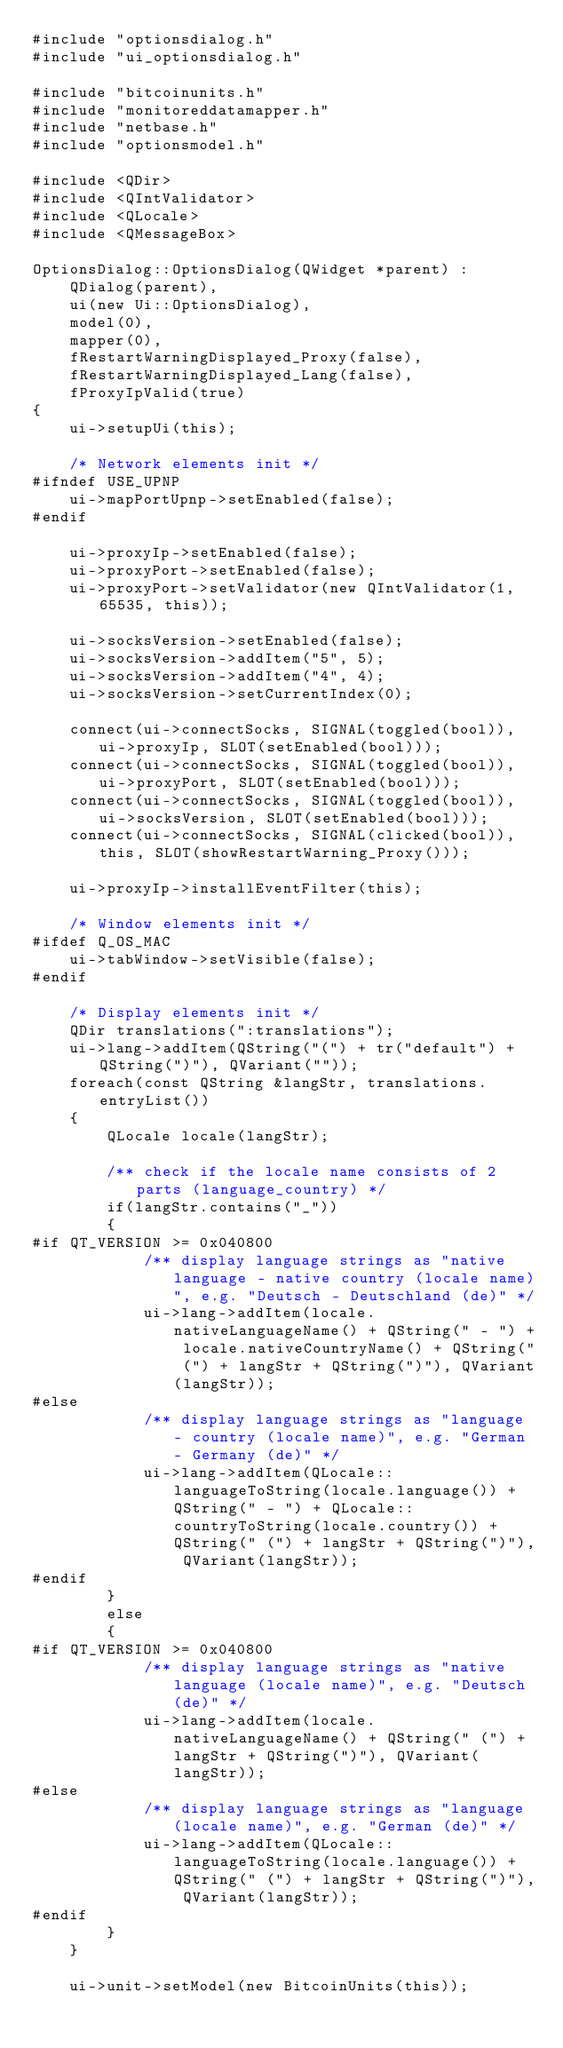Convert code to text. <code><loc_0><loc_0><loc_500><loc_500><_C++_>#include "optionsdialog.h"
#include "ui_optionsdialog.h"

#include "bitcoinunits.h"
#include "monitoreddatamapper.h"
#include "netbase.h"
#include "optionsmodel.h"

#include <QDir>
#include <QIntValidator>
#include <QLocale>
#include <QMessageBox>

OptionsDialog::OptionsDialog(QWidget *parent) :
    QDialog(parent),
    ui(new Ui::OptionsDialog),
    model(0),
    mapper(0),
    fRestartWarningDisplayed_Proxy(false),
    fRestartWarningDisplayed_Lang(false),
    fProxyIpValid(true)
{
    ui->setupUi(this);

    /* Network elements init */
#ifndef USE_UPNP
    ui->mapPortUpnp->setEnabled(false);
#endif

    ui->proxyIp->setEnabled(false);
    ui->proxyPort->setEnabled(false);
    ui->proxyPort->setValidator(new QIntValidator(1, 65535, this));

    ui->socksVersion->setEnabled(false);
    ui->socksVersion->addItem("5", 5);
    ui->socksVersion->addItem("4", 4);
    ui->socksVersion->setCurrentIndex(0);

    connect(ui->connectSocks, SIGNAL(toggled(bool)), ui->proxyIp, SLOT(setEnabled(bool)));
    connect(ui->connectSocks, SIGNAL(toggled(bool)), ui->proxyPort, SLOT(setEnabled(bool)));
    connect(ui->connectSocks, SIGNAL(toggled(bool)), ui->socksVersion, SLOT(setEnabled(bool)));
    connect(ui->connectSocks, SIGNAL(clicked(bool)), this, SLOT(showRestartWarning_Proxy()));

    ui->proxyIp->installEventFilter(this);

    /* Window elements init */
#ifdef Q_OS_MAC
    ui->tabWindow->setVisible(false);
#endif

    /* Display elements init */
    QDir translations(":translations");
    ui->lang->addItem(QString("(") + tr("default") + QString(")"), QVariant(""));
    foreach(const QString &langStr, translations.entryList())
    {
        QLocale locale(langStr);

        /** check if the locale name consists of 2 parts (language_country) */
        if(langStr.contains("_"))
        {
#if QT_VERSION >= 0x040800
            /** display language strings as "native language - native country (locale name)", e.g. "Deutsch - Deutschland (de)" */
            ui->lang->addItem(locale.nativeLanguageName() + QString(" - ") + locale.nativeCountryName() + QString(" (") + langStr + QString(")"), QVariant(langStr));
#else
            /** display language strings as "language - country (locale name)", e.g. "German - Germany (de)" */
            ui->lang->addItem(QLocale::languageToString(locale.language()) + QString(" - ") + QLocale::countryToString(locale.country()) + QString(" (") + langStr + QString(")"), QVariant(langStr));
#endif
        }
        else
        {
#if QT_VERSION >= 0x040800
            /** display language strings as "native language (locale name)", e.g. "Deutsch (de)" */
            ui->lang->addItem(locale.nativeLanguageName() + QString(" (") + langStr + QString(")"), QVariant(langStr));
#else
            /** display language strings as "language (locale name)", e.g. "German (de)" */
            ui->lang->addItem(QLocale::languageToString(locale.language()) + QString(" (") + langStr + QString(")"), QVariant(langStr));
#endif
        }
    }

    ui->unit->setModel(new BitcoinUnits(this));
</code> 